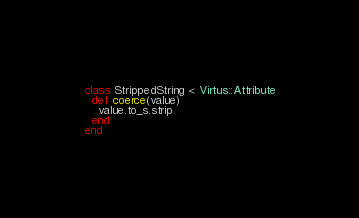Convert code to text. <code><loc_0><loc_0><loc_500><loc_500><_Ruby_>class StrippedString < Virtus::Attribute
  def coerce(value)
    value.to_s.strip
  end
end
</code> 